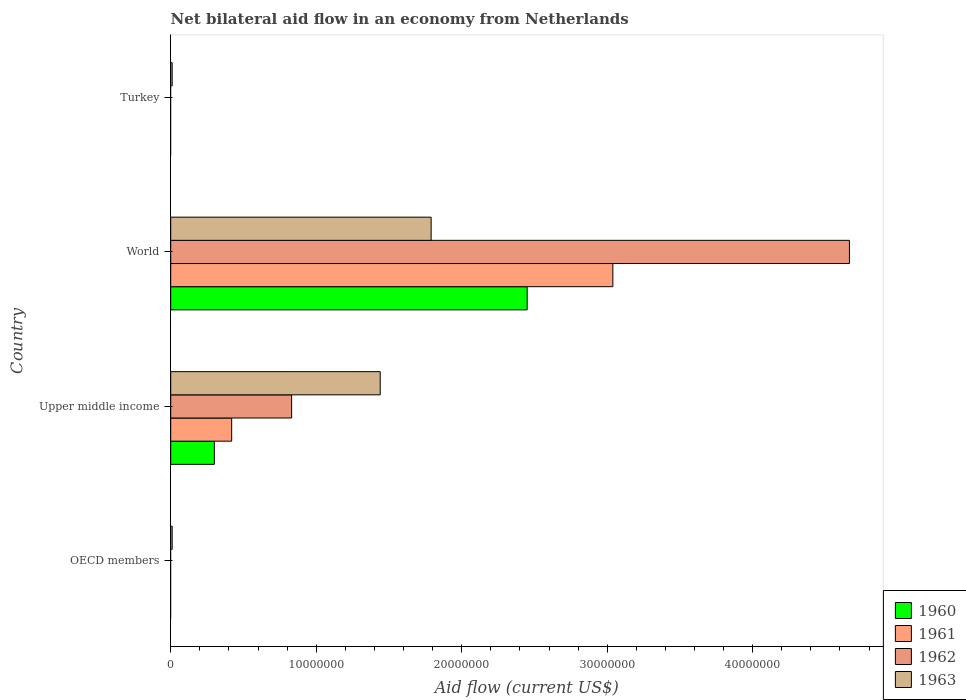How many different coloured bars are there?
Your answer should be compact. 4. Are the number of bars per tick equal to the number of legend labels?
Ensure brevity in your answer.  No. How many bars are there on the 2nd tick from the top?
Your response must be concise. 4. What is the net bilateral aid flow in 1960 in Upper middle income?
Offer a very short reply. 3.00e+06. Across all countries, what is the maximum net bilateral aid flow in 1961?
Provide a short and direct response. 3.04e+07. Across all countries, what is the minimum net bilateral aid flow in 1960?
Ensure brevity in your answer.  0. In which country was the net bilateral aid flow in 1962 maximum?
Make the answer very short. World. What is the total net bilateral aid flow in 1960 in the graph?
Your response must be concise. 2.75e+07. What is the difference between the net bilateral aid flow in 1961 in OECD members and the net bilateral aid flow in 1963 in World?
Your response must be concise. -1.79e+07. What is the average net bilateral aid flow in 1960 per country?
Ensure brevity in your answer.  6.88e+06. What is the difference between the net bilateral aid flow in 1961 and net bilateral aid flow in 1963 in Upper middle income?
Keep it short and to the point. -1.02e+07. What is the ratio of the net bilateral aid flow in 1963 in Upper middle income to that in World?
Keep it short and to the point. 0.8. Is the net bilateral aid flow in 1963 in Upper middle income less than that in World?
Your answer should be very brief. Yes. Is the difference between the net bilateral aid flow in 1961 in Upper middle income and World greater than the difference between the net bilateral aid flow in 1963 in Upper middle income and World?
Give a very brief answer. No. What is the difference between the highest and the second highest net bilateral aid flow in 1963?
Provide a short and direct response. 3.50e+06. What is the difference between the highest and the lowest net bilateral aid flow in 1963?
Offer a terse response. 1.78e+07. Is the sum of the net bilateral aid flow in 1963 in OECD members and World greater than the maximum net bilateral aid flow in 1962 across all countries?
Offer a terse response. No. How many countries are there in the graph?
Your answer should be very brief. 4. What is the difference between two consecutive major ticks on the X-axis?
Your answer should be very brief. 1.00e+07. Where does the legend appear in the graph?
Ensure brevity in your answer.  Bottom right. How are the legend labels stacked?
Offer a very short reply. Vertical. What is the title of the graph?
Offer a terse response. Net bilateral aid flow in an economy from Netherlands. What is the label or title of the X-axis?
Ensure brevity in your answer.  Aid flow (current US$). What is the Aid flow (current US$) in 1960 in OECD members?
Ensure brevity in your answer.  0. What is the Aid flow (current US$) in 1961 in OECD members?
Provide a short and direct response. 0. What is the Aid flow (current US$) of 1960 in Upper middle income?
Make the answer very short. 3.00e+06. What is the Aid flow (current US$) in 1961 in Upper middle income?
Offer a very short reply. 4.19e+06. What is the Aid flow (current US$) in 1962 in Upper middle income?
Offer a very short reply. 8.31e+06. What is the Aid flow (current US$) of 1963 in Upper middle income?
Ensure brevity in your answer.  1.44e+07. What is the Aid flow (current US$) in 1960 in World?
Offer a terse response. 2.45e+07. What is the Aid flow (current US$) of 1961 in World?
Offer a terse response. 3.04e+07. What is the Aid flow (current US$) in 1962 in World?
Provide a short and direct response. 4.66e+07. What is the Aid flow (current US$) in 1963 in World?
Ensure brevity in your answer.  1.79e+07. Across all countries, what is the maximum Aid flow (current US$) in 1960?
Your answer should be compact. 2.45e+07. Across all countries, what is the maximum Aid flow (current US$) of 1961?
Provide a succinct answer. 3.04e+07. Across all countries, what is the maximum Aid flow (current US$) in 1962?
Ensure brevity in your answer.  4.66e+07. Across all countries, what is the maximum Aid flow (current US$) in 1963?
Provide a succinct answer. 1.79e+07. Across all countries, what is the minimum Aid flow (current US$) of 1962?
Offer a very short reply. 0. What is the total Aid flow (current US$) of 1960 in the graph?
Provide a short and direct response. 2.75e+07. What is the total Aid flow (current US$) in 1961 in the graph?
Provide a short and direct response. 3.46e+07. What is the total Aid flow (current US$) in 1962 in the graph?
Your answer should be compact. 5.50e+07. What is the total Aid flow (current US$) in 1963 in the graph?
Offer a terse response. 3.25e+07. What is the difference between the Aid flow (current US$) of 1963 in OECD members and that in Upper middle income?
Ensure brevity in your answer.  -1.43e+07. What is the difference between the Aid flow (current US$) of 1963 in OECD members and that in World?
Ensure brevity in your answer.  -1.78e+07. What is the difference between the Aid flow (current US$) in 1960 in Upper middle income and that in World?
Your answer should be compact. -2.15e+07. What is the difference between the Aid flow (current US$) of 1961 in Upper middle income and that in World?
Keep it short and to the point. -2.62e+07. What is the difference between the Aid flow (current US$) in 1962 in Upper middle income and that in World?
Make the answer very short. -3.83e+07. What is the difference between the Aid flow (current US$) in 1963 in Upper middle income and that in World?
Your answer should be compact. -3.50e+06. What is the difference between the Aid flow (current US$) of 1963 in Upper middle income and that in Turkey?
Your answer should be very brief. 1.43e+07. What is the difference between the Aid flow (current US$) in 1963 in World and that in Turkey?
Ensure brevity in your answer.  1.78e+07. What is the difference between the Aid flow (current US$) of 1960 in Upper middle income and the Aid flow (current US$) of 1961 in World?
Give a very brief answer. -2.74e+07. What is the difference between the Aid flow (current US$) in 1960 in Upper middle income and the Aid flow (current US$) in 1962 in World?
Make the answer very short. -4.36e+07. What is the difference between the Aid flow (current US$) in 1960 in Upper middle income and the Aid flow (current US$) in 1963 in World?
Your response must be concise. -1.49e+07. What is the difference between the Aid flow (current US$) of 1961 in Upper middle income and the Aid flow (current US$) of 1962 in World?
Provide a succinct answer. -4.25e+07. What is the difference between the Aid flow (current US$) in 1961 in Upper middle income and the Aid flow (current US$) in 1963 in World?
Provide a short and direct response. -1.37e+07. What is the difference between the Aid flow (current US$) of 1962 in Upper middle income and the Aid flow (current US$) of 1963 in World?
Your response must be concise. -9.59e+06. What is the difference between the Aid flow (current US$) of 1960 in Upper middle income and the Aid flow (current US$) of 1963 in Turkey?
Your answer should be very brief. 2.90e+06. What is the difference between the Aid flow (current US$) of 1961 in Upper middle income and the Aid flow (current US$) of 1963 in Turkey?
Offer a terse response. 4.09e+06. What is the difference between the Aid flow (current US$) of 1962 in Upper middle income and the Aid flow (current US$) of 1963 in Turkey?
Offer a terse response. 8.21e+06. What is the difference between the Aid flow (current US$) in 1960 in World and the Aid flow (current US$) in 1963 in Turkey?
Offer a very short reply. 2.44e+07. What is the difference between the Aid flow (current US$) in 1961 in World and the Aid flow (current US$) in 1963 in Turkey?
Provide a succinct answer. 3.03e+07. What is the difference between the Aid flow (current US$) in 1962 in World and the Aid flow (current US$) in 1963 in Turkey?
Your answer should be very brief. 4.66e+07. What is the average Aid flow (current US$) in 1960 per country?
Your answer should be compact. 6.88e+06. What is the average Aid flow (current US$) in 1961 per country?
Ensure brevity in your answer.  8.64e+06. What is the average Aid flow (current US$) in 1962 per country?
Make the answer very short. 1.37e+07. What is the average Aid flow (current US$) of 1963 per country?
Ensure brevity in your answer.  8.12e+06. What is the difference between the Aid flow (current US$) of 1960 and Aid flow (current US$) of 1961 in Upper middle income?
Your response must be concise. -1.19e+06. What is the difference between the Aid flow (current US$) in 1960 and Aid flow (current US$) in 1962 in Upper middle income?
Ensure brevity in your answer.  -5.31e+06. What is the difference between the Aid flow (current US$) in 1960 and Aid flow (current US$) in 1963 in Upper middle income?
Your answer should be very brief. -1.14e+07. What is the difference between the Aid flow (current US$) in 1961 and Aid flow (current US$) in 1962 in Upper middle income?
Your response must be concise. -4.12e+06. What is the difference between the Aid flow (current US$) in 1961 and Aid flow (current US$) in 1963 in Upper middle income?
Keep it short and to the point. -1.02e+07. What is the difference between the Aid flow (current US$) of 1962 and Aid flow (current US$) of 1963 in Upper middle income?
Offer a very short reply. -6.09e+06. What is the difference between the Aid flow (current US$) in 1960 and Aid flow (current US$) in 1961 in World?
Provide a short and direct response. -5.89e+06. What is the difference between the Aid flow (current US$) in 1960 and Aid flow (current US$) in 1962 in World?
Offer a very short reply. -2.22e+07. What is the difference between the Aid flow (current US$) in 1960 and Aid flow (current US$) in 1963 in World?
Provide a succinct answer. 6.60e+06. What is the difference between the Aid flow (current US$) in 1961 and Aid flow (current US$) in 1962 in World?
Provide a short and direct response. -1.63e+07. What is the difference between the Aid flow (current US$) in 1961 and Aid flow (current US$) in 1963 in World?
Offer a terse response. 1.25e+07. What is the difference between the Aid flow (current US$) of 1962 and Aid flow (current US$) of 1963 in World?
Your answer should be very brief. 2.88e+07. What is the ratio of the Aid flow (current US$) in 1963 in OECD members to that in Upper middle income?
Offer a very short reply. 0.01. What is the ratio of the Aid flow (current US$) of 1963 in OECD members to that in World?
Give a very brief answer. 0.01. What is the ratio of the Aid flow (current US$) of 1963 in OECD members to that in Turkey?
Keep it short and to the point. 1. What is the ratio of the Aid flow (current US$) in 1960 in Upper middle income to that in World?
Offer a very short reply. 0.12. What is the ratio of the Aid flow (current US$) of 1961 in Upper middle income to that in World?
Your answer should be very brief. 0.14. What is the ratio of the Aid flow (current US$) of 1962 in Upper middle income to that in World?
Provide a succinct answer. 0.18. What is the ratio of the Aid flow (current US$) of 1963 in Upper middle income to that in World?
Your answer should be compact. 0.8. What is the ratio of the Aid flow (current US$) in 1963 in Upper middle income to that in Turkey?
Make the answer very short. 144. What is the ratio of the Aid flow (current US$) in 1963 in World to that in Turkey?
Offer a very short reply. 179. What is the difference between the highest and the second highest Aid flow (current US$) of 1963?
Keep it short and to the point. 3.50e+06. What is the difference between the highest and the lowest Aid flow (current US$) in 1960?
Your answer should be compact. 2.45e+07. What is the difference between the highest and the lowest Aid flow (current US$) in 1961?
Ensure brevity in your answer.  3.04e+07. What is the difference between the highest and the lowest Aid flow (current US$) in 1962?
Provide a short and direct response. 4.66e+07. What is the difference between the highest and the lowest Aid flow (current US$) in 1963?
Provide a succinct answer. 1.78e+07. 